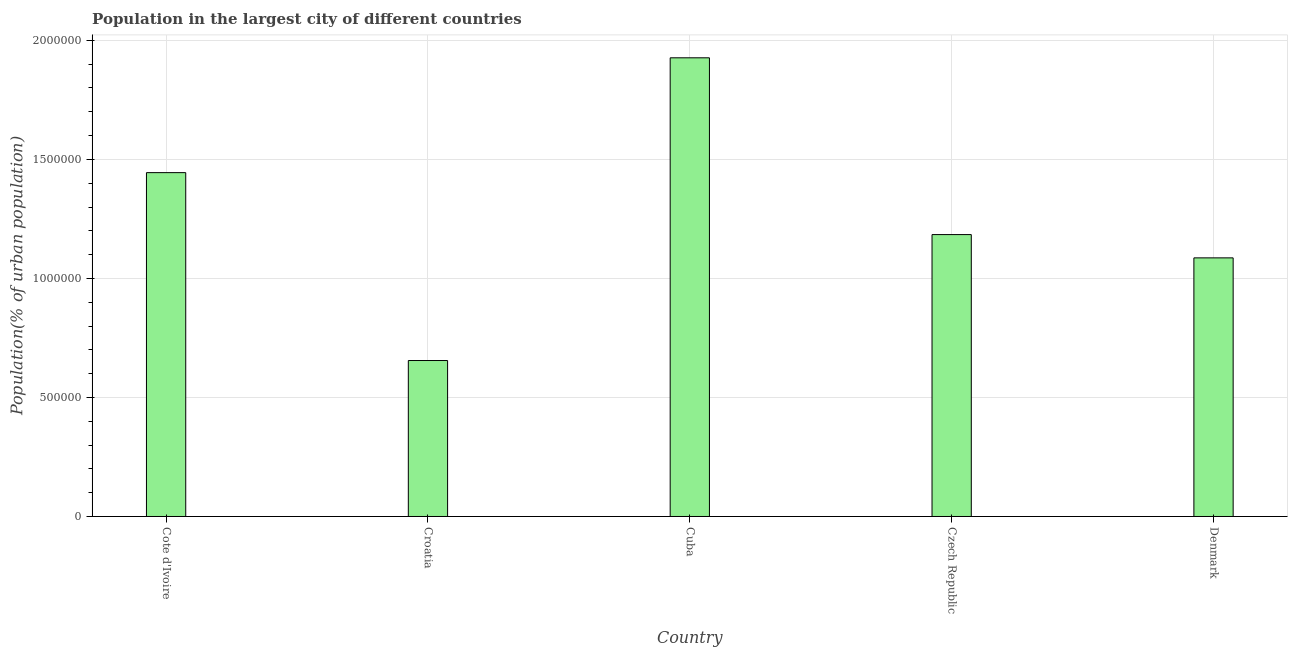What is the title of the graph?
Provide a short and direct response. Population in the largest city of different countries. What is the label or title of the X-axis?
Your answer should be compact. Country. What is the label or title of the Y-axis?
Your response must be concise. Population(% of urban population). What is the population in largest city in Denmark?
Offer a terse response. 1.09e+06. Across all countries, what is the maximum population in largest city?
Provide a short and direct response. 1.93e+06. Across all countries, what is the minimum population in largest city?
Your response must be concise. 6.55e+05. In which country was the population in largest city maximum?
Provide a succinct answer. Cuba. In which country was the population in largest city minimum?
Offer a terse response. Croatia. What is the sum of the population in largest city?
Make the answer very short. 6.30e+06. What is the difference between the population in largest city in Croatia and Denmark?
Your answer should be compact. -4.31e+05. What is the average population in largest city per country?
Offer a terse response. 1.26e+06. What is the median population in largest city?
Keep it short and to the point. 1.18e+06. In how many countries, is the population in largest city greater than 100000 %?
Your response must be concise. 5. What is the ratio of the population in largest city in Croatia to that in Czech Republic?
Provide a short and direct response. 0.55. Is the population in largest city in Cote d'Ivoire less than that in Denmark?
Your answer should be compact. No. What is the difference between the highest and the second highest population in largest city?
Your answer should be compact. 4.82e+05. Is the sum of the population in largest city in Croatia and Cuba greater than the maximum population in largest city across all countries?
Ensure brevity in your answer.  Yes. What is the difference between the highest and the lowest population in largest city?
Make the answer very short. 1.27e+06. In how many countries, is the population in largest city greater than the average population in largest city taken over all countries?
Offer a very short reply. 2. How many bars are there?
Make the answer very short. 5. What is the difference between two consecutive major ticks on the Y-axis?
Provide a short and direct response. 5.00e+05. Are the values on the major ticks of Y-axis written in scientific E-notation?
Keep it short and to the point. No. What is the Population(% of urban population) in Cote d'Ivoire?
Your answer should be very brief. 1.44e+06. What is the Population(% of urban population) of Croatia?
Give a very brief answer. 6.55e+05. What is the Population(% of urban population) of Cuba?
Offer a very short reply. 1.93e+06. What is the Population(% of urban population) of Czech Republic?
Provide a short and direct response. 1.18e+06. What is the Population(% of urban population) in Denmark?
Provide a short and direct response. 1.09e+06. What is the difference between the Population(% of urban population) in Cote d'Ivoire and Croatia?
Offer a terse response. 7.89e+05. What is the difference between the Population(% of urban population) in Cote d'Ivoire and Cuba?
Your answer should be compact. -4.82e+05. What is the difference between the Population(% of urban population) in Cote d'Ivoire and Czech Republic?
Provide a short and direct response. 2.60e+05. What is the difference between the Population(% of urban population) in Cote d'Ivoire and Denmark?
Offer a very short reply. 3.58e+05. What is the difference between the Population(% of urban population) in Croatia and Cuba?
Make the answer very short. -1.27e+06. What is the difference between the Population(% of urban population) in Croatia and Czech Republic?
Your answer should be compact. -5.29e+05. What is the difference between the Population(% of urban population) in Croatia and Denmark?
Offer a very short reply. -4.31e+05. What is the difference between the Population(% of urban population) in Cuba and Czech Republic?
Offer a terse response. 7.43e+05. What is the difference between the Population(% of urban population) in Cuba and Denmark?
Ensure brevity in your answer.  8.40e+05. What is the difference between the Population(% of urban population) in Czech Republic and Denmark?
Provide a short and direct response. 9.78e+04. What is the ratio of the Population(% of urban population) in Cote d'Ivoire to that in Croatia?
Keep it short and to the point. 2.21. What is the ratio of the Population(% of urban population) in Cote d'Ivoire to that in Cuba?
Your answer should be compact. 0.75. What is the ratio of the Population(% of urban population) in Cote d'Ivoire to that in Czech Republic?
Keep it short and to the point. 1.22. What is the ratio of the Population(% of urban population) in Cote d'Ivoire to that in Denmark?
Keep it short and to the point. 1.33. What is the ratio of the Population(% of urban population) in Croatia to that in Cuba?
Provide a succinct answer. 0.34. What is the ratio of the Population(% of urban population) in Croatia to that in Czech Republic?
Give a very brief answer. 0.55. What is the ratio of the Population(% of urban population) in Croatia to that in Denmark?
Provide a short and direct response. 0.6. What is the ratio of the Population(% of urban population) in Cuba to that in Czech Republic?
Ensure brevity in your answer.  1.63. What is the ratio of the Population(% of urban population) in Cuba to that in Denmark?
Keep it short and to the point. 1.77. What is the ratio of the Population(% of urban population) in Czech Republic to that in Denmark?
Offer a terse response. 1.09. 